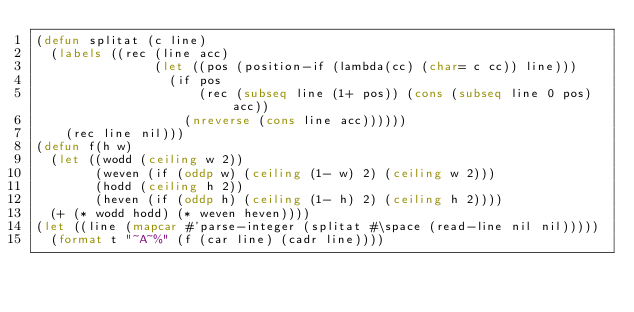<code> <loc_0><loc_0><loc_500><loc_500><_Lisp_>(defun splitat (c line)
  (labels ((rec (line acc)
				(let ((pos (position-if (lambda(cc) (char= c cc)) line)))
				  (if pos
					  (rec (subseq line (1+ pos)) (cons (subseq line 0 pos) acc))
					(nreverse (cons line acc))))))
	(rec line nil)))
(defun f(h w)
  (let ((wodd (ceiling w 2))
        (weven (if (oddp w) (ceiling (1- w) 2) (ceiling w 2)))
        (hodd (ceiling h 2))
        (heven (if (oddp h) (ceiling (1- h) 2) (ceiling h 2))))
  (+ (* wodd hodd) (* weven heven))))
(let ((line (mapcar #'parse-integer (splitat #\space (read-line nil nil)))))
  (format t "~A~%" (f (car line) (cadr line))))
</code> 